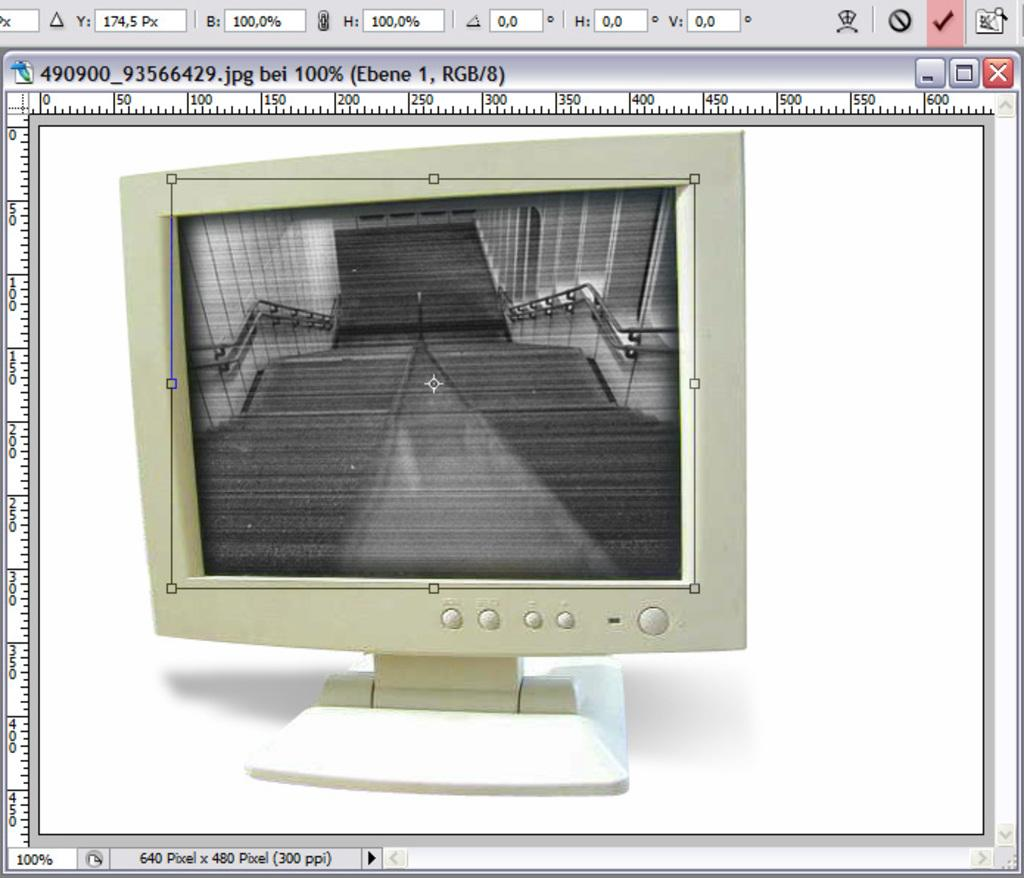<image>
Provide a brief description of the given image. A computer screen with a JPG file pulled up of a vintage computer monitor showing a black and white picture of stairs. 